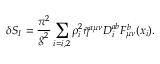Convert formula to latex. <formula><loc_0><loc_0><loc_500><loc_500>\delta S _ { I } = \frac { \pi ^ { 2 } } { g ^ { 2 } } \sum _ { i = i , 2 } \rho _ { i } ^ { 2 } \bar { \eta } ^ { a \mu \nu } D _ { i } ^ { a b } F _ { \mu \nu } ^ { b } ( x _ { i } ) .</formula> 